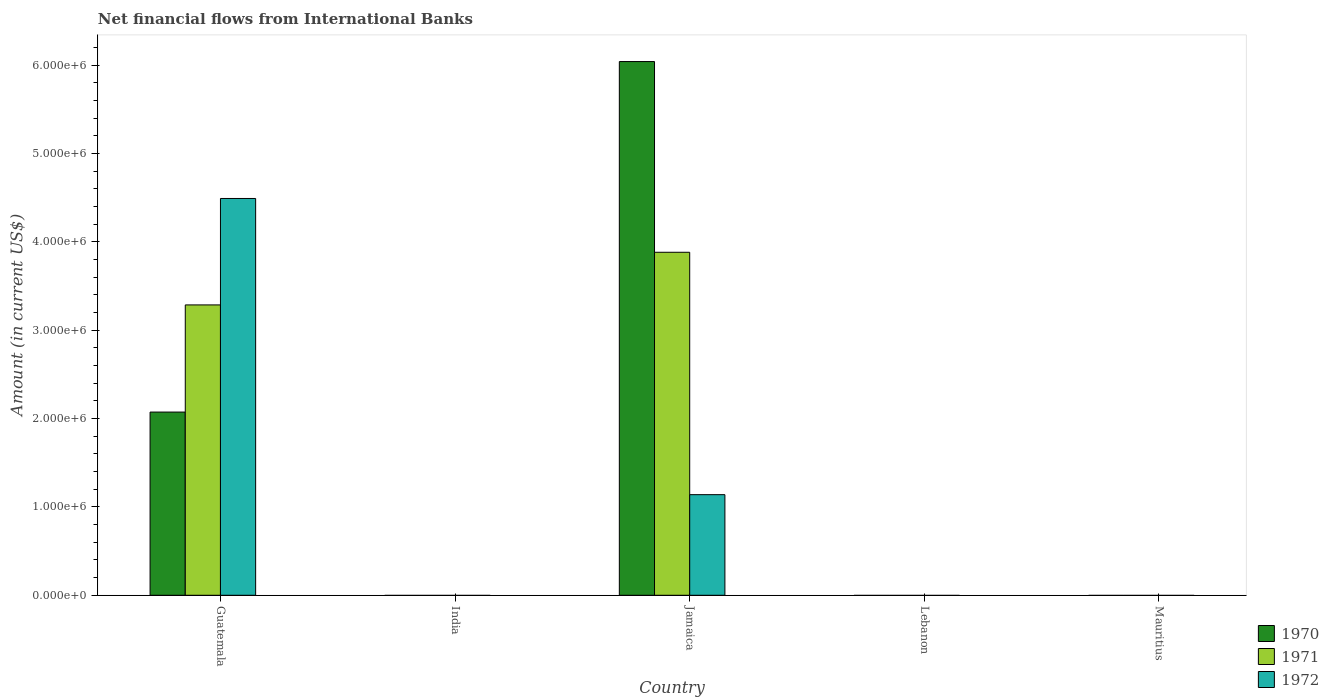How many different coloured bars are there?
Offer a very short reply. 3. Are the number of bars per tick equal to the number of legend labels?
Your answer should be compact. No. Are the number of bars on each tick of the X-axis equal?
Keep it short and to the point. No. Across all countries, what is the maximum net financial aid flows in 1970?
Ensure brevity in your answer.  6.04e+06. Across all countries, what is the minimum net financial aid flows in 1972?
Offer a very short reply. 0. In which country was the net financial aid flows in 1970 maximum?
Your answer should be very brief. Jamaica. What is the total net financial aid flows in 1971 in the graph?
Ensure brevity in your answer.  7.17e+06. What is the difference between the net financial aid flows in 1971 in Jamaica and the net financial aid flows in 1972 in India?
Keep it short and to the point. 3.88e+06. What is the average net financial aid flows in 1970 per country?
Keep it short and to the point. 1.62e+06. What is the difference between the net financial aid flows of/in 1972 and net financial aid flows of/in 1970 in Guatemala?
Ensure brevity in your answer.  2.42e+06. In how many countries, is the net financial aid flows in 1970 greater than 3600000 US$?
Give a very brief answer. 1. What is the ratio of the net financial aid flows in 1972 in Guatemala to that in Jamaica?
Offer a terse response. 3.94. Is the net financial aid flows in 1970 in Guatemala less than that in Jamaica?
Offer a very short reply. Yes. What is the difference between the highest and the lowest net financial aid flows in 1970?
Give a very brief answer. 6.04e+06. Is it the case that in every country, the sum of the net financial aid flows in 1971 and net financial aid flows in 1972 is greater than the net financial aid flows in 1970?
Give a very brief answer. No. How many bars are there?
Your answer should be compact. 6. Are all the bars in the graph horizontal?
Your answer should be very brief. No. What is the difference between two consecutive major ticks on the Y-axis?
Keep it short and to the point. 1.00e+06. Does the graph contain grids?
Offer a terse response. No. How many legend labels are there?
Offer a terse response. 3. How are the legend labels stacked?
Provide a succinct answer. Vertical. What is the title of the graph?
Your answer should be compact. Net financial flows from International Banks. What is the label or title of the X-axis?
Your response must be concise. Country. What is the label or title of the Y-axis?
Keep it short and to the point. Amount (in current US$). What is the Amount (in current US$) of 1970 in Guatemala?
Offer a very short reply. 2.07e+06. What is the Amount (in current US$) of 1971 in Guatemala?
Provide a succinct answer. 3.29e+06. What is the Amount (in current US$) in 1972 in Guatemala?
Provide a succinct answer. 4.49e+06. What is the Amount (in current US$) in 1970 in Jamaica?
Ensure brevity in your answer.  6.04e+06. What is the Amount (in current US$) in 1971 in Jamaica?
Provide a succinct answer. 3.88e+06. What is the Amount (in current US$) of 1972 in Jamaica?
Keep it short and to the point. 1.14e+06. What is the Amount (in current US$) of 1970 in Lebanon?
Your response must be concise. 0. What is the Amount (in current US$) in 1971 in Lebanon?
Offer a very short reply. 0. What is the Amount (in current US$) in 1972 in Lebanon?
Your response must be concise. 0. What is the Amount (in current US$) in 1971 in Mauritius?
Ensure brevity in your answer.  0. What is the Amount (in current US$) of 1972 in Mauritius?
Your response must be concise. 0. Across all countries, what is the maximum Amount (in current US$) in 1970?
Provide a short and direct response. 6.04e+06. Across all countries, what is the maximum Amount (in current US$) in 1971?
Make the answer very short. 3.88e+06. Across all countries, what is the maximum Amount (in current US$) in 1972?
Offer a very short reply. 4.49e+06. What is the total Amount (in current US$) of 1970 in the graph?
Make the answer very short. 8.12e+06. What is the total Amount (in current US$) of 1971 in the graph?
Ensure brevity in your answer.  7.17e+06. What is the total Amount (in current US$) in 1972 in the graph?
Your response must be concise. 5.63e+06. What is the difference between the Amount (in current US$) of 1970 in Guatemala and that in Jamaica?
Keep it short and to the point. -3.97e+06. What is the difference between the Amount (in current US$) of 1971 in Guatemala and that in Jamaica?
Your answer should be very brief. -5.96e+05. What is the difference between the Amount (in current US$) of 1972 in Guatemala and that in Jamaica?
Your answer should be compact. 3.35e+06. What is the difference between the Amount (in current US$) in 1970 in Guatemala and the Amount (in current US$) in 1971 in Jamaica?
Ensure brevity in your answer.  -1.81e+06. What is the difference between the Amount (in current US$) in 1970 in Guatemala and the Amount (in current US$) in 1972 in Jamaica?
Provide a succinct answer. 9.35e+05. What is the difference between the Amount (in current US$) of 1971 in Guatemala and the Amount (in current US$) of 1972 in Jamaica?
Ensure brevity in your answer.  2.15e+06. What is the average Amount (in current US$) of 1970 per country?
Your answer should be very brief. 1.62e+06. What is the average Amount (in current US$) of 1971 per country?
Give a very brief answer. 1.43e+06. What is the average Amount (in current US$) in 1972 per country?
Your answer should be very brief. 1.13e+06. What is the difference between the Amount (in current US$) of 1970 and Amount (in current US$) of 1971 in Guatemala?
Keep it short and to the point. -1.21e+06. What is the difference between the Amount (in current US$) of 1970 and Amount (in current US$) of 1972 in Guatemala?
Your answer should be compact. -2.42e+06. What is the difference between the Amount (in current US$) of 1971 and Amount (in current US$) of 1972 in Guatemala?
Keep it short and to the point. -1.20e+06. What is the difference between the Amount (in current US$) in 1970 and Amount (in current US$) in 1971 in Jamaica?
Offer a very short reply. 2.16e+06. What is the difference between the Amount (in current US$) in 1970 and Amount (in current US$) in 1972 in Jamaica?
Offer a very short reply. 4.90e+06. What is the difference between the Amount (in current US$) of 1971 and Amount (in current US$) of 1972 in Jamaica?
Your response must be concise. 2.74e+06. What is the ratio of the Amount (in current US$) of 1970 in Guatemala to that in Jamaica?
Make the answer very short. 0.34. What is the ratio of the Amount (in current US$) in 1971 in Guatemala to that in Jamaica?
Keep it short and to the point. 0.85. What is the ratio of the Amount (in current US$) in 1972 in Guatemala to that in Jamaica?
Your answer should be compact. 3.94. What is the difference between the highest and the lowest Amount (in current US$) in 1970?
Provide a short and direct response. 6.04e+06. What is the difference between the highest and the lowest Amount (in current US$) of 1971?
Provide a succinct answer. 3.88e+06. What is the difference between the highest and the lowest Amount (in current US$) of 1972?
Your answer should be very brief. 4.49e+06. 